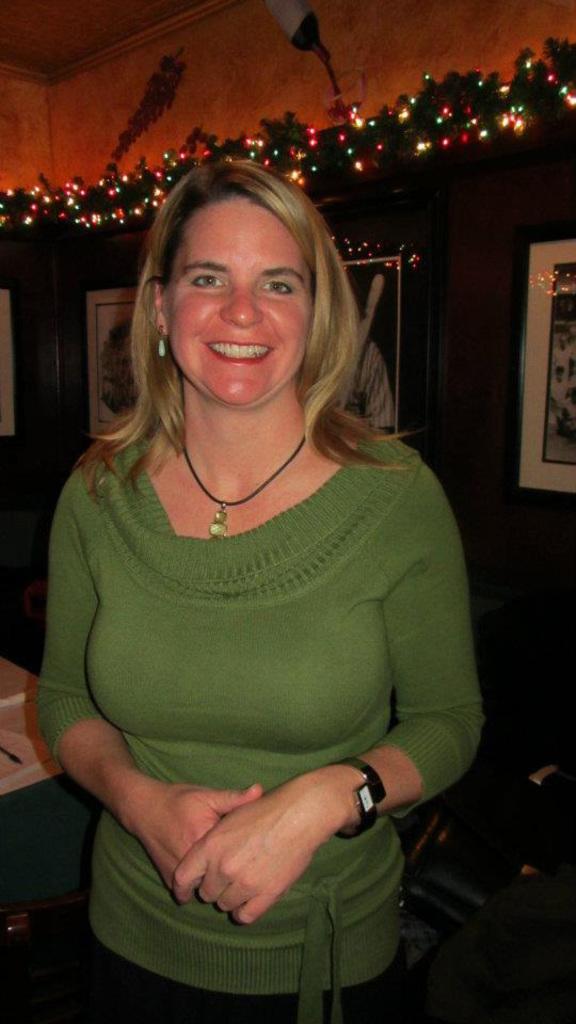How would you summarize this image in a sentence or two? This image is taken indoors. In the background there is a wall with a few picture frames on it and there are a few decorative items and rope lights on the wall. At the top of the image there is a ceiling. In the middle of the image a woman is standing and she is with a smiling face. 